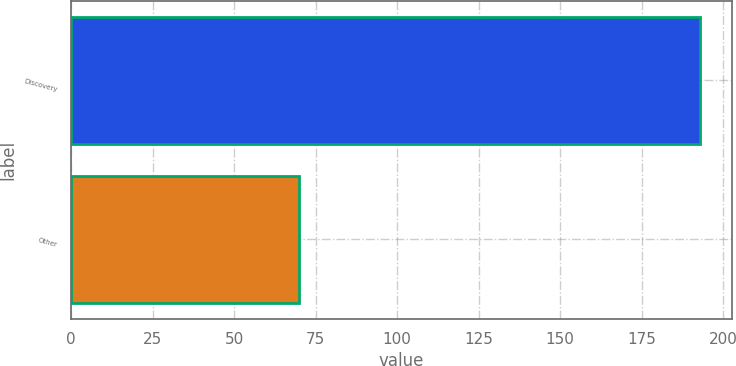Convert chart. <chart><loc_0><loc_0><loc_500><loc_500><bar_chart><fcel>Discovery<fcel>Other<nl><fcel>193<fcel>70<nl></chart> 